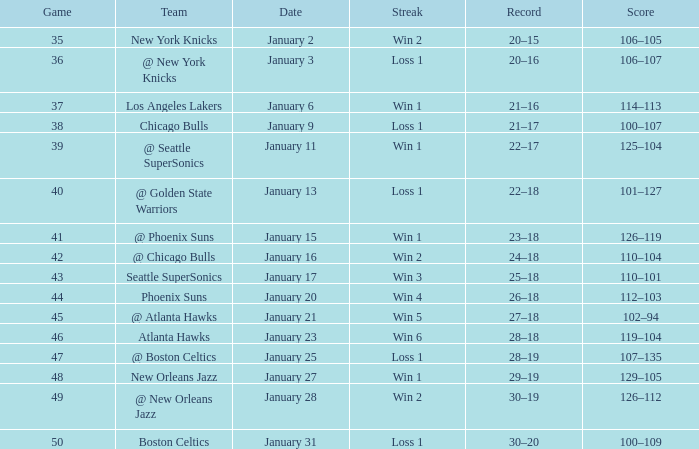What is the Team on January 20? Phoenix Suns. 